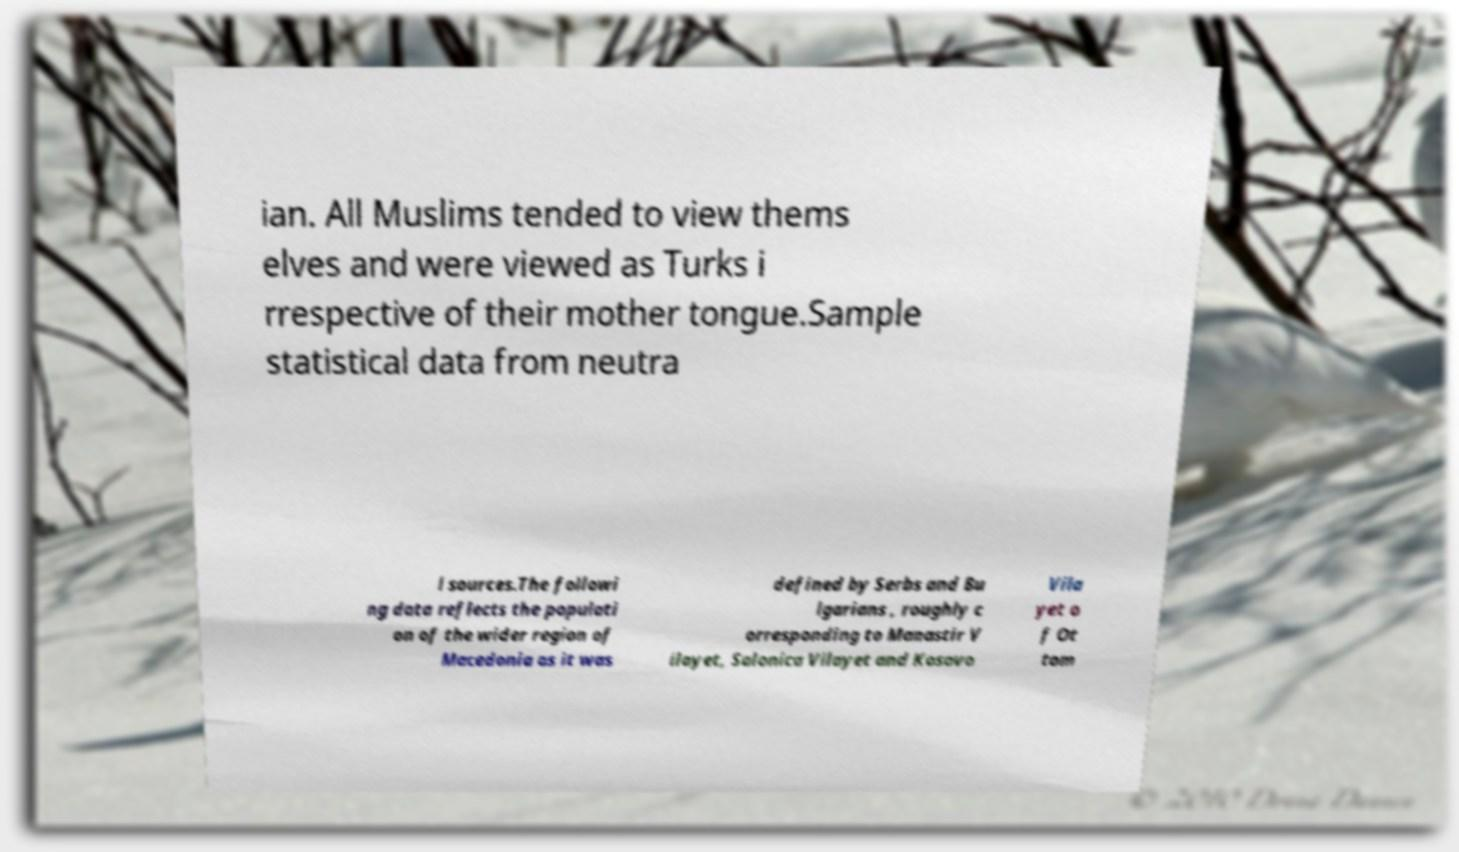Please identify and transcribe the text found in this image. ian. All Muslims tended to view thems elves and were viewed as Turks i rrespective of their mother tongue.Sample statistical data from neutra l sources.The followi ng data reflects the populati on of the wider region of Macedonia as it was defined by Serbs and Bu lgarians , roughly c orresponding to Manastir V ilayet, Salonica Vilayet and Kosovo Vila yet o f Ot tom 